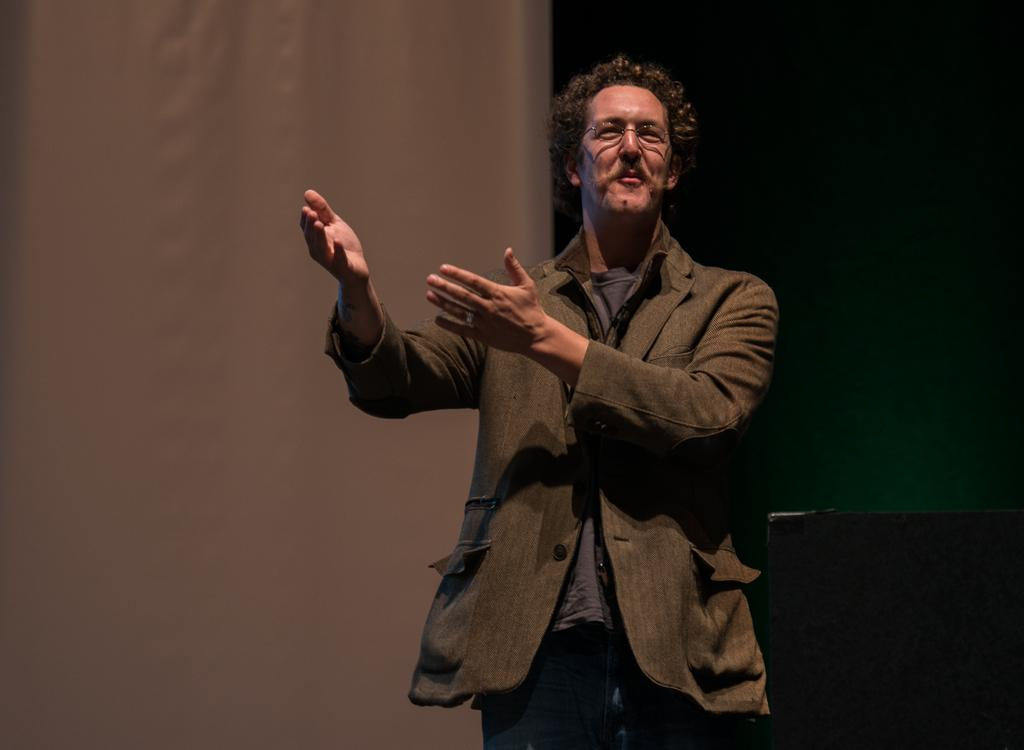What is the main subject of the image? There is a person in the image. What is the person wearing? The person is wearing a dress and specs. What colors can be seen in the background of the image? The background of the image is white and green in color. What can be seen on the right side of the image? There is a black object on the right side of the image. Can you describe the clouds in the image? There are no clouds visible in the image; the background is white and green. How does the person control the winter in the image? There is no indication of winter or control in the image; it features a person wearing a dress and specs with a white and green background and a black object on the right side. 